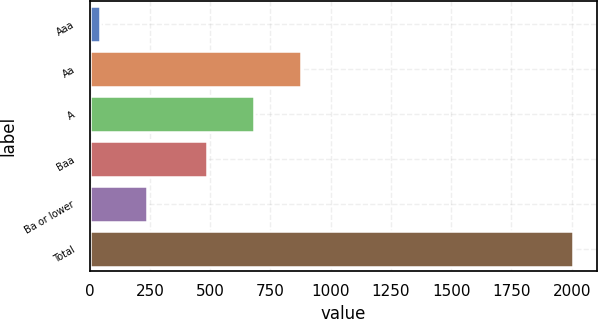Convert chart to OTSL. <chart><loc_0><loc_0><loc_500><loc_500><bar_chart><fcel>Aaa<fcel>Aa<fcel>A<fcel>Baa<fcel>Ba or lower<fcel>Total<nl><fcel>42<fcel>878.6<fcel>682.3<fcel>486<fcel>238.3<fcel>2005<nl></chart> 